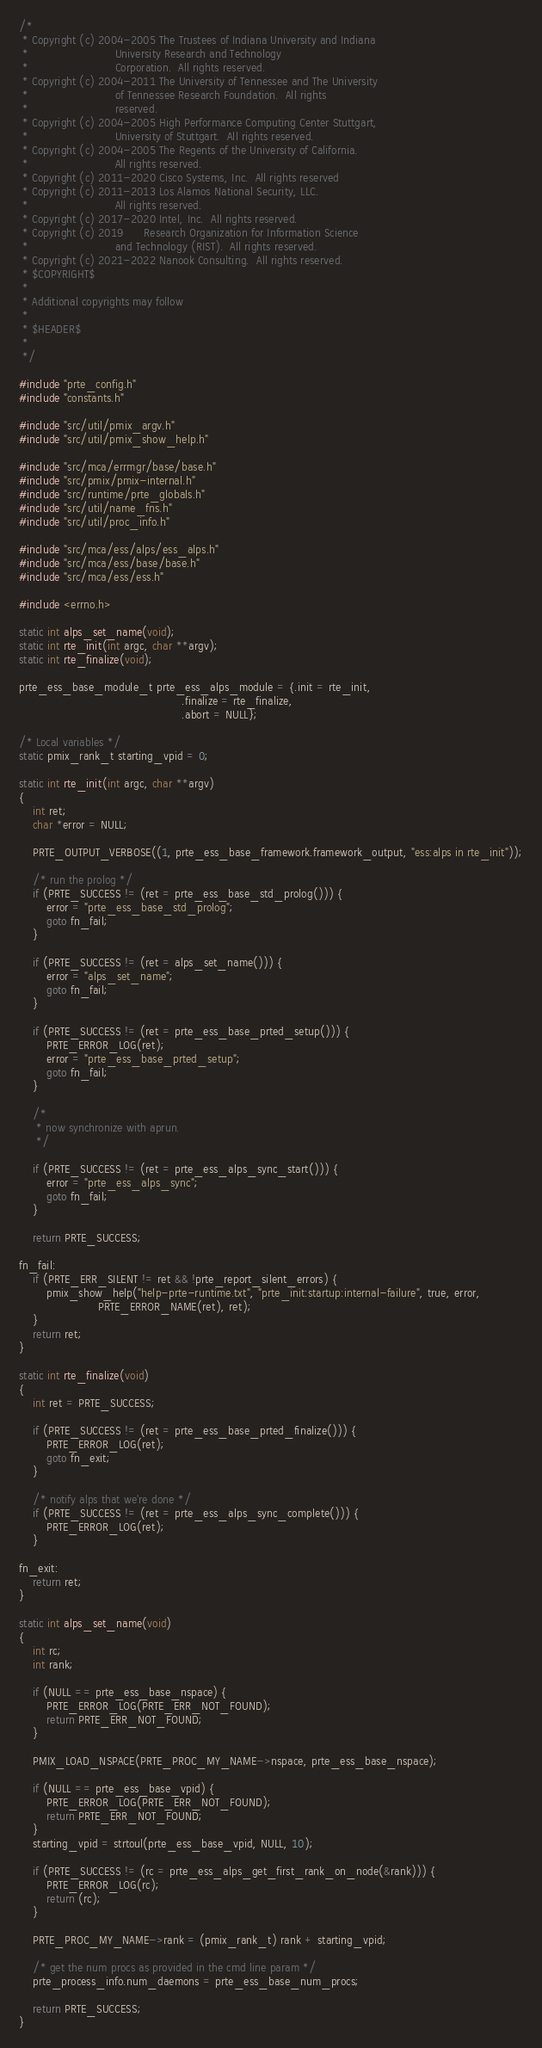<code> <loc_0><loc_0><loc_500><loc_500><_C_>/*
 * Copyright (c) 2004-2005 The Trustees of Indiana University and Indiana
 *                         University Research and Technology
 *                         Corporation.  All rights reserved.
 * Copyright (c) 2004-2011 The University of Tennessee and The University
 *                         of Tennessee Research Foundation.  All rights
 *                         reserved.
 * Copyright (c) 2004-2005 High Performance Computing Center Stuttgart,
 *                         University of Stuttgart.  All rights reserved.
 * Copyright (c) 2004-2005 The Regents of the University of California.
 *                         All rights reserved.
 * Copyright (c) 2011-2020 Cisco Systems, Inc.  All rights reserved
 * Copyright (c) 2011-2013 Los Alamos National Security, LLC.
 *                         All rights reserved.
 * Copyright (c) 2017-2020 Intel, Inc.  All rights reserved.
 * Copyright (c) 2019      Research Organization for Information Science
 *                         and Technology (RIST).  All rights reserved.
 * Copyright (c) 2021-2022 Nanook Consulting.  All rights reserved.
 * $COPYRIGHT$
 *
 * Additional copyrights may follow
 *
 * $HEADER$
 *
 */

#include "prte_config.h"
#include "constants.h"

#include "src/util/pmix_argv.h"
#include "src/util/pmix_show_help.h"

#include "src/mca/errmgr/base/base.h"
#include "src/pmix/pmix-internal.h"
#include "src/runtime/prte_globals.h"
#include "src/util/name_fns.h"
#include "src/util/proc_info.h"

#include "src/mca/ess/alps/ess_alps.h"
#include "src/mca/ess/base/base.h"
#include "src/mca/ess/ess.h"

#include <errno.h>

static int alps_set_name(void);
static int rte_init(int argc, char **argv);
static int rte_finalize(void);

prte_ess_base_module_t prte_ess_alps_module = {.init = rte_init,
                                               .finalize = rte_finalize,
                                               .abort = NULL};

/* Local variables */
static pmix_rank_t starting_vpid = 0;

static int rte_init(int argc, char **argv)
{
    int ret;
    char *error = NULL;

    PRTE_OUTPUT_VERBOSE((1, prte_ess_base_framework.framework_output, "ess:alps in rte_init"));

    /* run the prolog */
    if (PRTE_SUCCESS != (ret = prte_ess_base_std_prolog())) {
        error = "prte_ess_base_std_prolog";
        goto fn_fail;
    }

    if (PRTE_SUCCESS != (ret = alps_set_name())) {
        error = "alps_set_name";
        goto fn_fail;
    }

    if (PRTE_SUCCESS != (ret = prte_ess_base_prted_setup())) {
        PRTE_ERROR_LOG(ret);
        error = "prte_ess_base_prted_setup";
        goto fn_fail;
    }

    /*
     * now synchronize with aprun.
     */

    if (PRTE_SUCCESS != (ret = prte_ess_alps_sync_start())) {
        error = "prte_ess_alps_sync";
        goto fn_fail;
    }

    return PRTE_SUCCESS;

fn_fail:
    if (PRTE_ERR_SILENT != ret && !prte_report_silent_errors) {
        pmix_show_help("help-prte-runtime.txt", "prte_init:startup:internal-failure", true, error,
                       PRTE_ERROR_NAME(ret), ret);
    }
    return ret;
}

static int rte_finalize(void)
{
    int ret = PRTE_SUCCESS;

    if (PRTE_SUCCESS != (ret = prte_ess_base_prted_finalize())) {
        PRTE_ERROR_LOG(ret);
        goto fn_exit;
    }

    /* notify alps that we're done */
    if (PRTE_SUCCESS != (ret = prte_ess_alps_sync_complete())) {
        PRTE_ERROR_LOG(ret);
    }

fn_exit:
    return ret;
}

static int alps_set_name(void)
{
    int rc;
    int rank;

    if (NULL == prte_ess_base_nspace) {
        PRTE_ERROR_LOG(PRTE_ERR_NOT_FOUND);
        return PRTE_ERR_NOT_FOUND;
    }

    PMIX_LOAD_NSPACE(PRTE_PROC_MY_NAME->nspace, prte_ess_base_nspace);

    if (NULL == prte_ess_base_vpid) {
        PRTE_ERROR_LOG(PRTE_ERR_NOT_FOUND);
        return PRTE_ERR_NOT_FOUND;
    }
    starting_vpid = strtoul(prte_ess_base_vpid, NULL, 10);

    if (PRTE_SUCCESS != (rc = prte_ess_alps_get_first_rank_on_node(&rank))) {
        PRTE_ERROR_LOG(rc);
        return (rc);
    }

    PRTE_PROC_MY_NAME->rank = (pmix_rank_t) rank + starting_vpid;

    /* get the num procs as provided in the cmd line param */
    prte_process_info.num_daemons = prte_ess_base_num_procs;

    return PRTE_SUCCESS;
}
</code> 